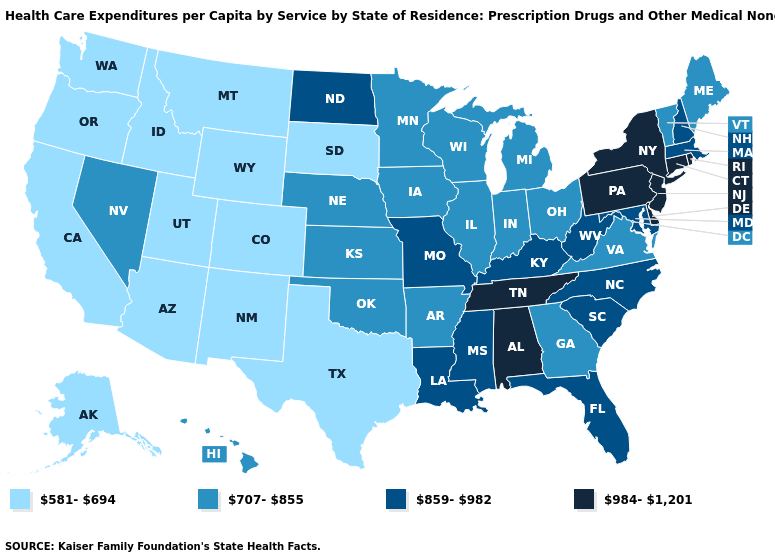Name the states that have a value in the range 984-1,201?
Concise answer only. Alabama, Connecticut, Delaware, New Jersey, New York, Pennsylvania, Rhode Island, Tennessee. Which states have the lowest value in the West?
Answer briefly. Alaska, Arizona, California, Colorado, Idaho, Montana, New Mexico, Oregon, Utah, Washington, Wyoming. What is the value of South Carolina?
Write a very short answer. 859-982. Does Utah have a lower value than Alaska?
Quick response, please. No. What is the highest value in the West ?
Give a very brief answer. 707-855. What is the lowest value in states that border Oklahoma?
Short answer required. 581-694. What is the value of Kentucky?
Answer briefly. 859-982. Does the map have missing data?
Give a very brief answer. No. What is the value of Pennsylvania?
Keep it brief. 984-1,201. Does the first symbol in the legend represent the smallest category?
Short answer required. Yes. Among the states that border Mississippi , does Tennessee have the highest value?
Short answer required. Yes. What is the value of Minnesota?
Keep it brief. 707-855. Name the states that have a value in the range 707-855?
Quick response, please. Arkansas, Georgia, Hawaii, Illinois, Indiana, Iowa, Kansas, Maine, Michigan, Minnesota, Nebraska, Nevada, Ohio, Oklahoma, Vermont, Virginia, Wisconsin. What is the value of Illinois?
Answer briefly. 707-855. 